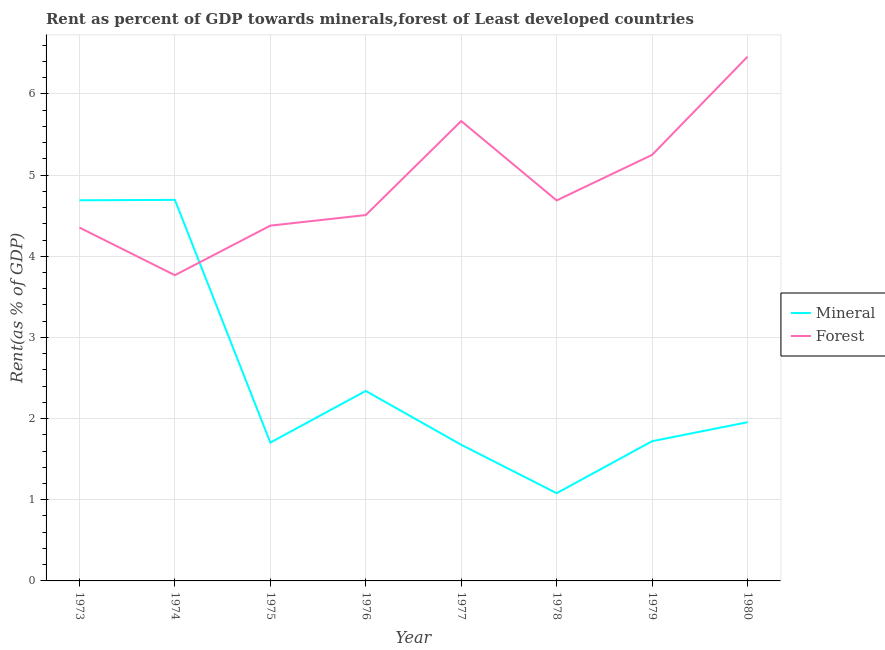Does the line corresponding to forest rent intersect with the line corresponding to mineral rent?
Ensure brevity in your answer.  Yes. Is the number of lines equal to the number of legend labels?
Make the answer very short. Yes. What is the mineral rent in 1975?
Offer a very short reply. 1.7. Across all years, what is the maximum mineral rent?
Provide a succinct answer. 4.69. Across all years, what is the minimum forest rent?
Keep it short and to the point. 3.77. In which year was the forest rent minimum?
Keep it short and to the point. 1974. What is the total forest rent in the graph?
Ensure brevity in your answer.  39.07. What is the difference between the forest rent in 1977 and that in 1979?
Provide a succinct answer. 0.42. What is the difference between the forest rent in 1978 and the mineral rent in 1979?
Offer a very short reply. 2.97. What is the average mineral rent per year?
Your answer should be compact. 2.48. In the year 1976, what is the difference between the forest rent and mineral rent?
Make the answer very short. 2.17. In how many years, is the forest rent greater than 4.2 %?
Provide a short and direct response. 7. What is the ratio of the forest rent in 1977 to that in 1978?
Provide a succinct answer. 1.21. Is the forest rent in 1977 less than that in 1978?
Provide a succinct answer. No. Is the difference between the mineral rent in 1976 and 1979 greater than the difference between the forest rent in 1976 and 1979?
Provide a succinct answer. Yes. What is the difference between the highest and the second highest forest rent?
Provide a short and direct response. 0.79. What is the difference between the highest and the lowest mineral rent?
Make the answer very short. 3.61. Is the sum of the forest rent in 1977 and 1978 greater than the maximum mineral rent across all years?
Give a very brief answer. Yes. Does the mineral rent monotonically increase over the years?
Your answer should be compact. No. Is the forest rent strictly less than the mineral rent over the years?
Offer a terse response. No. Are the values on the major ticks of Y-axis written in scientific E-notation?
Keep it short and to the point. No. Does the graph contain any zero values?
Your answer should be very brief. No. How many legend labels are there?
Keep it short and to the point. 2. How are the legend labels stacked?
Provide a succinct answer. Vertical. What is the title of the graph?
Provide a succinct answer. Rent as percent of GDP towards minerals,forest of Least developed countries. What is the label or title of the Y-axis?
Make the answer very short. Rent(as % of GDP). What is the Rent(as % of GDP) in Mineral in 1973?
Your response must be concise. 4.69. What is the Rent(as % of GDP) of Forest in 1973?
Make the answer very short. 4.35. What is the Rent(as % of GDP) of Mineral in 1974?
Provide a succinct answer. 4.69. What is the Rent(as % of GDP) in Forest in 1974?
Your response must be concise. 3.77. What is the Rent(as % of GDP) in Mineral in 1975?
Keep it short and to the point. 1.7. What is the Rent(as % of GDP) of Forest in 1975?
Offer a very short reply. 4.38. What is the Rent(as % of GDP) in Mineral in 1976?
Make the answer very short. 2.34. What is the Rent(as % of GDP) of Forest in 1976?
Keep it short and to the point. 4.51. What is the Rent(as % of GDP) of Mineral in 1977?
Offer a very short reply. 1.68. What is the Rent(as % of GDP) in Forest in 1977?
Your response must be concise. 5.67. What is the Rent(as % of GDP) in Mineral in 1978?
Give a very brief answer. 1.08. What is the Rent(as % of GDP) of Forest in 1978?
Your answer should be compact. 4.69. What is the Rent(as % of GDP) in Mineral in 1979?
Ensure brevity in your answer.  1.72. What is the Rent(as % of GDP) in Forest in 1979?
Offer a very short reply. 5.25. What is the Rent(as % of GDP) of Mineral in 1980?
Keep it short and to the point. 1.96. What is the Rent(as % of GDP) of Forest in 1980?
Make the answer very short. 6.46. Across all years, what is the maximum Rent(as % of GDP) in Mineral?
Provide a short and direct response. 4.69. Across all years, what is the maximum Rent(as % of GDP) of Forest?
Your answer should be very brief. 6.46. Across all years, what is the minimum Rent(as % of GDP) of Mineral?
Offer a very short reply. 1.08. Across all years, what is the minimum Rent(as % of GDP) in Forest?
Offer a very short reply. 3.77. What is the total Rent(as % of GDP) in Mineral in the graph?
Your answer should be compact. 19.87. What is the total Rent(as % of GDP) of Forest in the graph?
Ensure brevity in your answer.  39.07. What is the difference between the Rent(as % of GDP) in Mineral in 1973 and that in 1974?
Your answer should be very brief. -0. What is the difference between the Rent(as % of GDP) in Forest in 1973 and that in 1974?
Ensure brevity in your answer.  0.59. What is the difference between the Rent(as % of GDP) in Mineral in 1973 and that in 1975?
Ensure brevity in your answer.  2.99. What is the difference between the Rent(as % of GDP) of Forest in 1973 and that in 1975?
Your response must be concise. -0.02. What is the difference between the Rent(as % of GDP) in Mineral in 1973 and that in 1976?
Offer a terse response. 2.35. What is the difference between the Rent(as % of GDP) of Forest in 1973 and that in 1976?
Give a very brief answer. -0.15. What is the difference between the Rent(as % of GDP) of Mineral in 1973 and that in 1977?
Your response must be concise. 3.01. What is the difference between the Rent(as % of GDP) in Forest in 1973 and that in 1977?
Your answer should be compact. -1.31. What is the difference between the Rent(as % of GDP) in Mineral in 1973 and that in 1978?
Ensure brevity in your answer.  3.61. What is the difference between the Rent(as % of GDP) in Forest in 1973 and that in 1978?
Ensure brevity in your answer.  -0.33. What is the difference between the Rent(as % of GDP) of Mineral in 1973 and that in 1979?
Your response must be concise. 2.97. What is the difference between the Rent(as % of GDP) in Forest in 1973 and that in 1979?
Ensure brevity in your answer.  -0.9. What is the difference between the Rent(as % of GDP) of Mineral in 1973 and that in 1980?
Provide a succinct answer. 2.73. What is the difference between the Rent(as % of GDP) of Forest in 1973 and that in 1980?
Give a very brief answer. -2.11. What is the difference between the Rent(as % of GDP) in Mineral in 1974 and that in 1975?
Your answer should be compact. 2.99. What is the difference between the Rent(as % of GDP) of Forest in 1974 and that in 1975?
Your response must be concise. -0.61. What is the difference between the Rent(as % of GDP) in Mineral in 1974 and that in 1976?
Your answer should be compact. 2.35. What is the difference between the Rent(as % of GDP) in Forest in 1974 and that in 1976?
Ensure brevity in your answer.  -0.74. What is the difference between the Rent(as % of GDP) of Mineral in 1974 and that in 1977?
Your response must be concise. 3.02. What is the difference between the Rent(as % of GDP) of Forest in 1974 and that in 1977?
Make the answer very short. -1.9. What is the difference between the Rent(as % of GDP) of Mineral in 1974 and that in 1978?
Ensure brevity in your answer.  3.61. What is the difference between the Rent(as % of GDP) in Forest in 1974 and that in 1978?
Your answer should be very brief. -0.92. What is the difference between the Rent(as % of GDP) in Mineral in 1974 and that in 1979?
Provide a short and direct response. 2.97. What is the difference between the Rent(as % of GDP) of Forest in 1974 and that in 1979?
Your answer should be compact. -1.48. What is the difference between the Rent(as % of GDP) in Mineral in 1974 and that in 1980?
Your answer should be very brief. 2.74. What is the difference between the Rent(as % of GDP) of Forest in 1974 and that in 1980?
Ensure brevity in your answer.  -2.69. What is the difference between the Rent(as % of GDP) of Mineral in 1975 and that in 1976?
Make the answer very short. -0.64. What is the difference between the Rent(as % of GDP) of Forest in 1975 and that in 1976?
Your answer should be compact. -0.13. What is the difference between the Rent(as % of GDP) in Mineral in 1975 and that in 1977?
Provide a succinct answer. 0.03. What is the difference between the Rent(as % of GDP) in Forest in 1975 and that in 1977?
Give a very brief answer. -1.29. What is the difference between the Rent(as % of GDP) in Mineral in 1975 and that in 1978?
Ensure brevity in your answer.  0.62. What is the difference between the Rent(as % of GDP) in Forest in 1975 and that in 1978?
Offer a terse response. -0.31. What is the difference between the Rent(as % of GDP) in Mineral in 1975 and that in 1979?
Offer a terse response. -0.02. What is the difference between the Rent(as % of GDP) of Forest in 1975 and that in 1979?
Provide a short and direct response. -0.87. What is the difference between the Rent(as % of GDP) in Mineral in 1975 and that in 1980?
Provide a succinct answer. -0.25. What is the difference between the Rent(as % of GDP) of Forest in 1975 and that in 1980?
Your answer should be compact. -2.08. What is the difference between the Rent(as % of GDP) in Mineral in 1976 and that in 1977?
Provide a short and direct response. 0.66. What is the difference between the Rent(as % of GDP) of Forest in 1976 and that in 1977?
Offer a terse response. -1.16. What is the difference between the Rent(as % of GDP) in Mineral in 1976 and that in 1978?
Provide a succinct answer. 1.26. What is the difference between the Rent(as % of GDP) of Forest in 1976 and that in 1978?
Make the answer very short. -0.18. What is the difference between the Rent(as % of GDP) in Mineral in 1976 and that in 1979?
Provide a short and direct response. 0.62. What is the difference between the Rent(as % of GDP) in Forest in 1976 and that in 1979?
Offer a terse response. -0.74. What is the difference between the Rent(as % of GDP) of Mineral in 1976 and that in 1980?
Ensure brevity in your answer.  0.39. What is the difference between the Rent(as % of GDP) in Forest in 1976 and that in 1980?
Offer a terse response. -1.95. What is the difference between the Rent(as % of GDP) of Mineral in 1977 and that in 1978?
Provide a short and direct response. 0.6. What is the difference between the Rent(as % of GDP) of Forest in 1977 and that in 1978?
Provide a succinct answer. 0.98. What is the difference between the Rent(as % of GDP) in Mineral in 1977 and that in 1979?
Provide a succinct answer. -0.04. What is the difference between the Rent(as % of GDP) in Forest in 1977 and that in 1979?
Offer a very short reply. 0.42. What is the difference between the Rent(as % of GDP) in Mineral in 1977 and that in 1980?
Provide a short and direct response. -0.28. What is the difference between the Rent(as % of GDP) of Forest in 1977 and that in 1980?
Keep it short and to the point. -0.79. What is the difference between the Rent(as % of GDP) in Mineral in 1978 and that in 1979?
Your response must be concise. -0.64. What is the difference between the Rent(as % of GDP) of Forest in 1978 and that in 1979?
Provide a short and direct response. -0.56. What is the difference between the Rent(as % of GDP) of Mineral in 1978 and that in 1980?
Your response must be concise. -0.87. What is the difference between the Rent(as % of GDP) in Forest in 1978 and that in 1980?
Your answer should be very brief. -1.77. What is the difference between the Rent(as % of GDP) of Mineral in 1979 and that in 1980?
Keep it short and to the point. -0.23. What is the difference between the Rent(as % of GDP) of Forest in 1979 and that in 1980?
Provide a succinct answer. -1.21. What is the difference between the Rent(as % of GDP) in Mineral in 1973 and the Rent(as % of GDP) in Forest in 1974?
Offer a very short reply. 0.92. What is the difference between the Rent(as % of GDP) of Mineral in 1973 and the Rent(as % of GDP) of Forest in 1975?
Your answer should be compact. 0.31. What is the difference between the Rent(as % of GDP) of Mineral in 1973 and the Rent(as % of GDP) of Forest in 1976?
Make the answer very short. 0.18. What is the difference between the Rent(as % of GDP) in Mineral in 1973 and the Rent(as % of GDP) in Forest in 1977?
Ensure brevity in your answer.  -0.98. What is the difference between the Rent(as % of GDP) of Mineral in 1973 and the Rent(as % of GDP) of Forest in 1978?
Your answer should be very brief. 0. What is the difference between the Rent(as % of GDP) in Mineral in 1973 and the Rent(as % of GDP) in Forest in 1979?
Your answer should be very brief. -0.56. What is the difference between the Rent(as % of GDP) of Mineral in 1973 and the Rent(as % of GDP) of Forest in 1980?
Provide a succinct answer. -1.77. What is the difference between the Rent(as % of GDP) in Mineral in 1974 and the Rent(as % of GDP) in Forest in 1975?
Make the answer very short. 0.32. What is the difference between the Rent(as % of GDP) in Mineral in 1974 and the Rent(as % of GDP) in Forest in 1976?
Keep it short and to the point. 0.19. What is the difference between the Rent(as % of GDP) in Mineral in 1974 and the Rent(as % of GDP) in Forest in 1977?
Provide a succinct answer. -0.97. What is the difference between the Rent(as % of GDP) of Mineral in 1974 and the Rent(as % of GDP) of Forest in 1978?
Keep it short and to the point. 0.01. What is the difference between the Rent(as % of GDP) in Mineral in 1974 and the Rent(as % of GDP) in Forest in 1979?
Make the answer very short. -0.55. What is the difference between the Rent(as % of GDP) in Mineral in 1974 and the Rent(as % of GDP) in Forest in 1980?
Your answer should be very brief. -1.76. What is the difference between the Rent(as % of GDP) of Mineral in 1975 and the Rent(as % of GDP) of Forest in 1976?
Your answer should be compact. -2.8. What is the difference between the Rent(as % of GDP) in Mineral in 1975 and the Rent(as % of GDP) in Forest in 1977?
Ensure brevity in your answer.  -3.96. What is the difference between the Rent(as % of GDP) in Mineral in 1975 and the Rent(as % of GDP) in Forest in 1978?
Your response must be concise. -2.98. What is the difference between the Rent(as % of GDP) of Mineral in 1975 and the Rent(as % of GDP) of Forest in 1979?
Provide a succinct answer. -3.54. What is the difference between the Rent(as % of GDP) in Mineral in 1975 and the Rent(as % of GDP) in Forest in 1980?
Your response must be concise. -4.75. What is the difference between the Rent(as % of GDP) in Mineral in 1976 and the Rent(as % of GDP) in Forest in 1977?
Offer a terse response. -3.33. What is the difference between the Rent(as % of GDP) of Mineral in 1976 and the Rent(as % of GDP) of Forest in 1978?
Your response must be concise. -2.35. What is the difference between the Rent(as % of GDP) in Mineral in 1976 and the Rent(as % of GDP) in Forest in 1979?
Ensure brevity in your answer.  -2.91. What is the difference between the Rent(as % of GDP) in Mineral in 1976 and the Rent(as % of GDP) in Forest in 1980?
Keep it short and to the point. -4.12. What is the difference between the Rent(as % of GDP) in Mineral in 1977 and the Rent(as % of GDP) in Forest in 1978?
Your answer should be very brief. -3.01. What is the difference between the Rent(as % of GDP) in Mineral in 1977 and the Rent(as % of GDP) in Forest in 1979?
Your answer should be compact. -3.57. What is the difference between the Rent(as % of GDP) in Mineral in 1977 and the Rent(as % of GDP) in Forest in 1980?
Provide a succinct answer. -4.78. What is the difference between the Rent(as % of GDP) in Mineral in 1978 and the Rent(as % of GDP) in Forest in 1979?
Make the answer very short. -4.17. What is the difference between the Rent(as % of GDP) of Mineral in 1978 and the Rent(as % of GDP) of Forest in 1980?
Ensure brevity in your answer.  -5.38. What is the difference between the Rent(as % of GDP) in Mineral in 1979 and the Rent(as % of GDP) in Forest in 1980?
Make the answer very short. -4.74. What is the average Rent(as % of GDP) in Mineral per year?
Offer a very short reply. 2.48. What is the average Rent(as % of GDP) of Forest per year?
Ensure brevity in your answer.  4.88. In the year 1973, what is the difference between the Rent(as % of GDP) in Mineral and Rent(as % of GDP) in Forest?
Your answer should be very brief. 0.34. In the year 1974, what is the difference between the Rent(as % of GDP) in Mineral and Rent(as % of GDP) in Forest?
Your response must be concise. 0.93. In the year 1975, what is the difference between the Rent(as % of GDP) of Mineral and Rent(as % of GDP) of Forest?
Offer a very short reply. -2.67. In the year 1976, what is the difference between the Rent(as % of GDP) in Mineral and Rent(as % of GDP) in Forest?
Give a very brief answer. -2.17. In the year 1977, what is the difference between the Rent(as % of GDP) in Mineral and Rent(as % of GDP) in Forest?
Make the answer very short. -3.99. In the year 1978, what is the difference between the Rent(as % of GDP) in Mineral and Rent(as % of GDP) in Forest?
Give a very brief answer. -3.61. In the year 1979, what is the difference between the Rent(as % of GDP) in Mineral and Rent(as % of GDP) in Forest?
Offer a terse response. -3.53. In the year 1980, what is the difference between the Rent(as % of GDP) of Mineral and Rent(as % of GDP) of Forest?
Give a very brief answer. -4.5. What is the ratio of the Rent(as % of GDP) in Forest in 1973 to that in 1974?
Make the answer very short. 1.16. What is the ratio of the Rent(as % of GDP) in Mineral in 1973 to that in 1975?
Ensure brevity in your answer.  2.75. What is the ratio of the Rent(as % of GDP) of Forest in 1973 to that in 1975?
Make the answer very short. 0.99. What is the ratio of the Rent(as % of GDP) of Mineral in 1973 to that in 1976?
Give a very brief answer. 2. What is the ratio of the Rent(as % of GDP) of Forest in 1973 to that in 1976?
Provide a short and direct response. 0.97. What is the ratio of the Rent(as % of GDP) in Mineral in 1973 to that in 1977?
Offer a terse response. 2.8. What is the ratio of the Rent(as % of GDP) of Forest in 1973 to that in 1977?
Keep it short and to the point. 0.77. What is the ratio of the Rent(as % of GDP) in Mineral in 1973 to that in 1978?
Provide a short and direct response. 4.34. What is the ratio of the Rent(as % of GDP) of Forest in 1973 to that in 1978?
Offer a terse response. 0.93. What is the ratio of the Rent(as % of GDP) in Mineral in 1973 to that in 1979?
Ensure brevity in your answer.  2.72. What is the ratio of the Rent(as % of GDP) of Forest in 1973 to that in 1979?
Offer a terse response. 0.83. What is the ratio of the Rent(as % of GDP) of Mineral in 1973 to that in 1980?
Ensure brevity in your answer.  2.4. What is the ratio of the Rent(as % of GDP) of Forest in 1973 to that in 1980?
Your answer should be very brief. 0.67. What is the ratio of the Rent(as % of GDP) of Mineral in 1974 to that in 1975?
Make the answer very short. 2.75. What is the ratio of the Rent(as % of GDP) of Forest in 1974 to that in 1975?
Offer a very short reply. 0.86. What is the ratio of the Rent(as % of GDP) of Mineral in 1974 to that in 1976?
Give a very brief answer. 2.01. What is the ratio of the Rent(as % of GDP) in Forest in 1974 to that in 1976?
Give a very brief answer. 0.84. What is the ratio of the Rent(as % of GDP) of Mineral in 1974 to that in 1977?
Offer a terse response. 2.8. What is the ratio of the Rent(as % of GDP) in Forest in 1974 to that in 1977?
Keep it short and to the point. 0.66. What is the ratio of the Rent(as % of GDP) in Mineral in 1974 to that in 1978?
Your answer should be compact. 4.34. What is the ratio of the Rent(as % of GDP) of Forest in 1974 to that in 1978?
Provide a short and direct response. 0.8. What is the ratio of the Rent(as % of GDP) of Mineral in 1974 to that in 1979?
Your answer should be very brief. 2.73. What is the ratio of the Rent(as % of GDP) in Forest in 1974 to that in 1979?
Provide a succinct answer. 0.72. What is the ratio of the Rent(as % of GDP) of Mineral in 1974 to that in 1980?
Ensure brevity in your answer.  2.4. What is the ratio of the Rent(as % of GDP) in Forest in 1974 to that in 1980?
Ensure brevity in your answer.  0.58. What is the ratio of the Rent(as % of GDP) in Mineral in 1975 to that in 1976?
Provide a succinct answer. 0.73. What is the ratio of the Rent(as % of GDP) in Forest in 1975 to that in 1976?
Ensure brevity in your answer.  0.97. What is the ratio of the Rent(as % of GDP) in Forest in 1975 to that in 1977?
Make the answer very short. 0.77. What is the ratio of the Rent(as % of GDP) in Mineral in 1975 to that in 1978?
Keep it short and to the point. 1.58. What is the ratio of the Rent(as % of GDP) in Forest in 1975 to that in 1978?
Offer a terse response. 0.93. What is the ratio of the Rent(as % of GDP) in Mineral in 1975 to that in 1979?
Offer a terse response. 0.99. What is the ratio of the Rent(as % of GDP) of Forest in 1975 to that in 1979?
Give a very brief answer. 0.83. What is the ratio of the Rent(as % of GDP) of Mineral in 1975 to that in 1980?
Ensure brevity in your answer.  0.87. What is the ratio of the Rent(as % of GDP) of Forest in 1975 to that in 1980?
Keep it short and to the point. 0.68. What is the ratio of the Rent(as % of GDP) of Mineral in 1976 to that in 1977?
Offer a terse response. 1.4. What is the ratio of the Rent(as % of GDP) of Forest in 1976 to that in 1977?
Make the answer very short. 0.8. What is the ratio of the Rent(as % of GDP) in Mineral in 1976 to that in 1978?
Offer a very short reply. 2.17. What is the ratio of the Rent(as % of GDP) of Forest in 1976 to that in 1978?
Your response must be concise. 0.96. What is the ratio of the Rent(as % of GDP) of Mineral in 1976 to that in 1979?
Ensure brevity in your answer.  1.36. What is the ratio of the Rent(as % of GDP) in Forest in 1976 to that in 1979?
Your answer should be compact. 0.86. What is the ratio of the Rent(as % of GDP) in Mineral in 1976 to that in 1980?
Provide a short and direct response. 1.2. What is the ratio of the Rent(as % of GDP) in Forest in 1976 to that in 1980?
Provide a short and direct response. 0.7. What is the ratio of the Rent(as % of GDP) in Mineral in 1977 to that in 1978?
Your answer should be very brief. 1.55. What is the ratio of the Rent(as % of GDP) in Forest in 1977 to that in 1978?
Ensure brevity in your answer.  1.21. What is the ratio of the Rent(as % of GDP) of Mineral in 1977 to that in 1979?
Keep it short and to the point. 0.97. What is the ratio of the Rent(as % of GDP) in Forest in 1977 to that in 1979?
Provide a short and direct response. 1.08. What is the ratio of the Rent(as % of GDP) in Mineral in 1977 to that in 1980?
Your answer should be compact. 0.86. What is the ratio of the Rent(as % of GDP) of Forest in 1977 to that in 1980?
Your answer should be very brief. 0.88. What is the ratio of the Rent(as % of GDP) of Mineral in 1978 to that in 1979?
Ensure brevity in your answer.  0.63. What is the ratio of the Rent(as % of GDP) of Forest in 1978 to that in 1979?
Offer a very short reply. 0.89. What is the ratio of the Rent(as % of GDP) in Mineral in 1978 to that in 1980?
Your answer should be very brief. 0.55. What is the ratio of the Rent(as % of GDP) of Forest in 1978 to that in 1980?
Provide a succinct answer. 0.73. What is the ratio of the Rent(as % of GDP) of Mineral in 1979 to that in 1980?
Provide a short and direct response. 0.88. What is the ratio of the Rent(as % of GDP) of Forest in 1979 to that in 1980?
Your response must be concise. 0.81. What is the difference between the highest and the second highest Rent(as % of GDP) in Mineral?
Offer a terse response. 0. What is the difference between the highest and the second highest Rent(as % of GDP) in Forest?
Offer a terse response. 0.79. What is the difference between the highest and the lowest Rent(as % of GDP) in Mineral?
Your response must be concise. 3.61. What is the difference between the highest and the lowest Rent(as % of GDP) of Forest?
Your answer should be very brief. 2.69. 